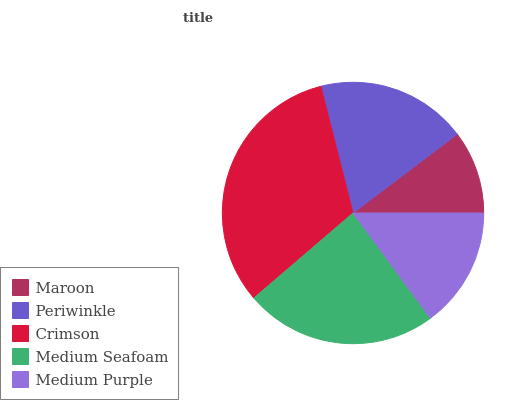Is Maroon the minimum?
Answer yes or no. Yes. Is Crimson the maximum?
Answer yes or no. Yes. Is Periwinkle the minimum?
Answer yes or no. No. Is Periwinkle the maximum?
Answer yes or no. No. Is Periwinkle greater than Maroon?
Answer yes or no. Yes. Is Maroon less than Periwinkle?
Answer yes or no. Yes. Is Maroon greater than Periwinkle?
Answer yes or no. No. Is Periwinkle less than Maroon?
Answer yes or no. No. Is Periwinkle the high median?
Answer yes or no. Yes. Is Periwinkle the low median?
Answer yes or no. Yes. Is Crimson the high median?
Answer yes or no. No. Is Medium Seafoam the low median?
Answer yes or no. No. 